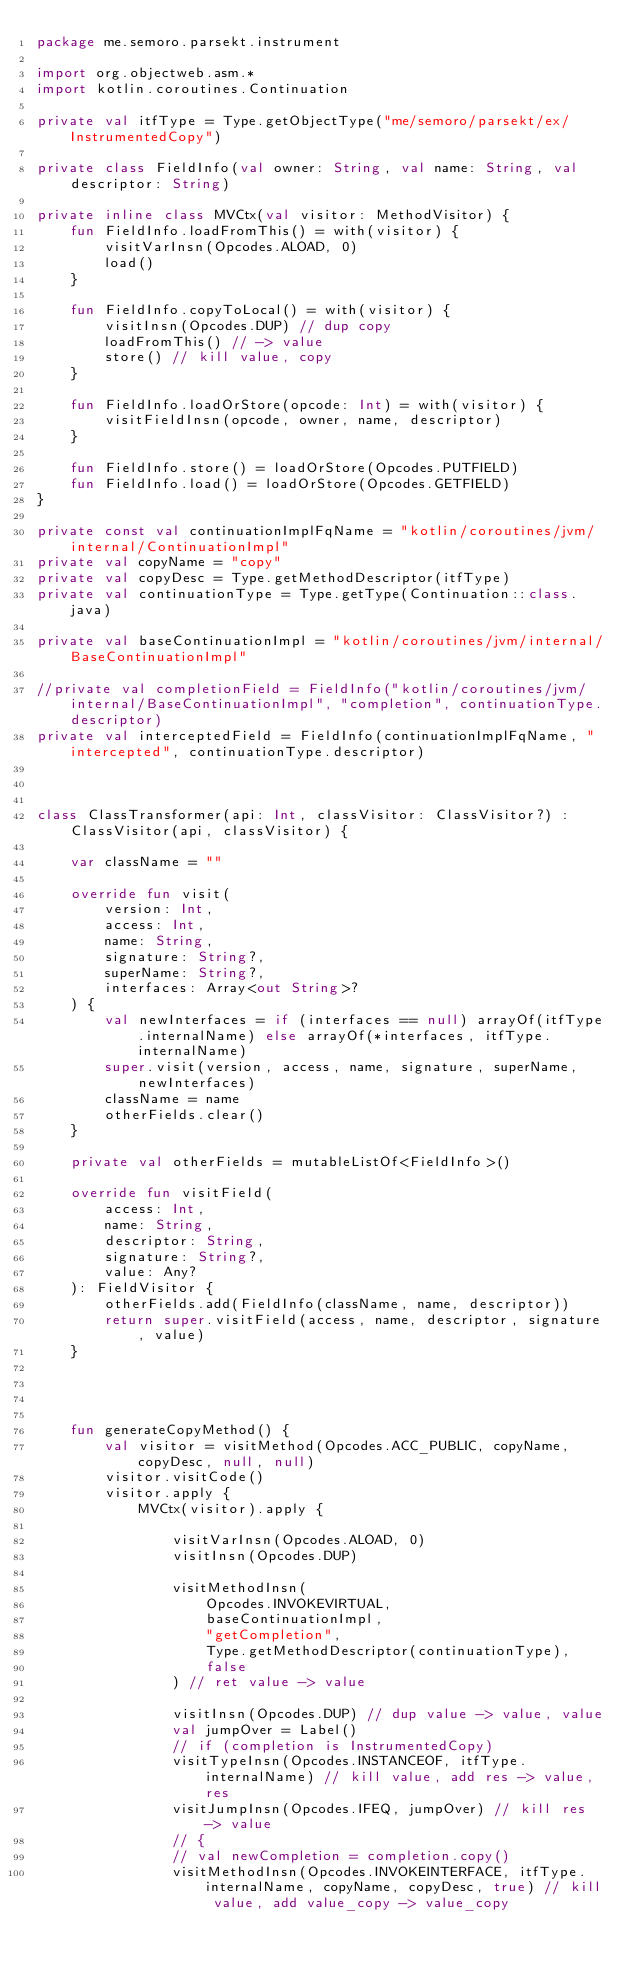Convert code to text. <code><loc_0><loc_0><loc_500><loc_500><_Kotlin_>package me.semoro.parsekt.instrument

import org.objectweb.asm.*
import kotlin.coroutines.Continuation

private val itfType = Type.getObjectType("me/semoro/parsekt/ex/InstrumentedCopy")

private class FieldInfo(val owner: String, val name: String, val descriptor: String)

private inline class MVCtx(val visitor: MethodVisitor) {
    fun FieldInfo.loadFromThis() = with(visitor) {
        visitVarInsn(Opcodes.ALOAD, 0)
        load()
    }

    fun FieldInfo.copyToLocal() = with(visitor) {
        visitInsn(Opcodes.DUP) // dup copy
        loadFromThis() // -> value
        store() // kill value, copy
    }

    fun FieldInfo.loadOrStore(opcode: Int) = with(visitor) {
        visitFieldInsn(opcode, owner, name, descriptor)
    }

    fun FieldInfo.store() = loadOrStore(Opcodes.PUTFIELD)
    fun FieldInfo.load() = loadOrStore(Opcodes.GETFIELD)
}

private const val continuationImplFqName = "kotlin/coroutines/jvm/internal/ContinuationImpl"
private val copyName = "copy"
private val copyDesc = Type.getMethodDescriptor(itfType)
private val continuationType = Type.getType(Continuation::class.java)

private val baseContinuationImpl = "kotlin/coroutines/jvm/internal/BaseContinuationImpl"

//private val completionField = FieldInfo("kotlin/coroutines/jvm/internal/BaseContinuationImpl", "completion", continuationType.descriptor)
private val interceptedField = FieldInfo(continuationImplFqName, "intercepted", continuationType.descriptor)



class ClassTransformer(api: Int, classVisitor: ClassVisitor?) : ClassVisitor(api, classVisitor) {

    var className = ""

    override fun visit(
        version: Int,
        access: Int,
        name: String,
        signature: String?,
        superName: String?,
        interfaces: Array<out String>?
    ) {
        val newInterfaces = if (interfaces == null) arrayOf(itfType.internalName) else arrayOf(*interfaces, itfType.internalName)
        super.visit(version, access, name, signature, superName, newInterfaces)
        className = name
        otherFields.clear()
    }

    private val otherFields = mutableListOf<FieldInfo>()

    override fun visitField(
        access: Int,
        name: String,
        descriptor: String,
        signature: String?,
        value: Any?
    ): FieldVisitor {
        otherFields.add(FieldInfo(className, name, descriptor))
        return super.visitField(access, name, descriptor, signature, value)
    }




    fun generateCopyMethod() {
        val visitor = visitMethod(Opcodes.ACC_PUBLIC, copyName, copyDesc, null, null)
        visitor.visitCode()
        visitor.apply {
            MVCtx(visitor).apply {

                visitVarInsn(Opcodes.ALOAD, 0)
                visitInsn(Opcodes.DUP)

                visitMethodInsn(
                    Opcodes.INVOKEVIRTUAL,
                    baseContinuationImpl,
                    "getCompletion",
                    Type.getMethodDescriptor(continuationType),
                    false
                ) // ret value -> value

                visitInsn(Opcodes.DUP) // dup value -> value, value
                val jumpOver = Label()
                // if (completion is InstrumentedCopy)
                visitTypeInsn(Opcodes.INSTANCEOF, itfType.internalName) // kill value, add res -> value, res
                visitJumpInsn(Opcodes.IFEQ, jumpOver) // kill res -> value
                // {
                // val newCompletion = completion.copy()
                visitMethodInsn(Opcodes.INVOKEINTERFACE, itfType.internalName, copyName, copyDesc, true) // kill value, add value_copy -> value_copy</code> 